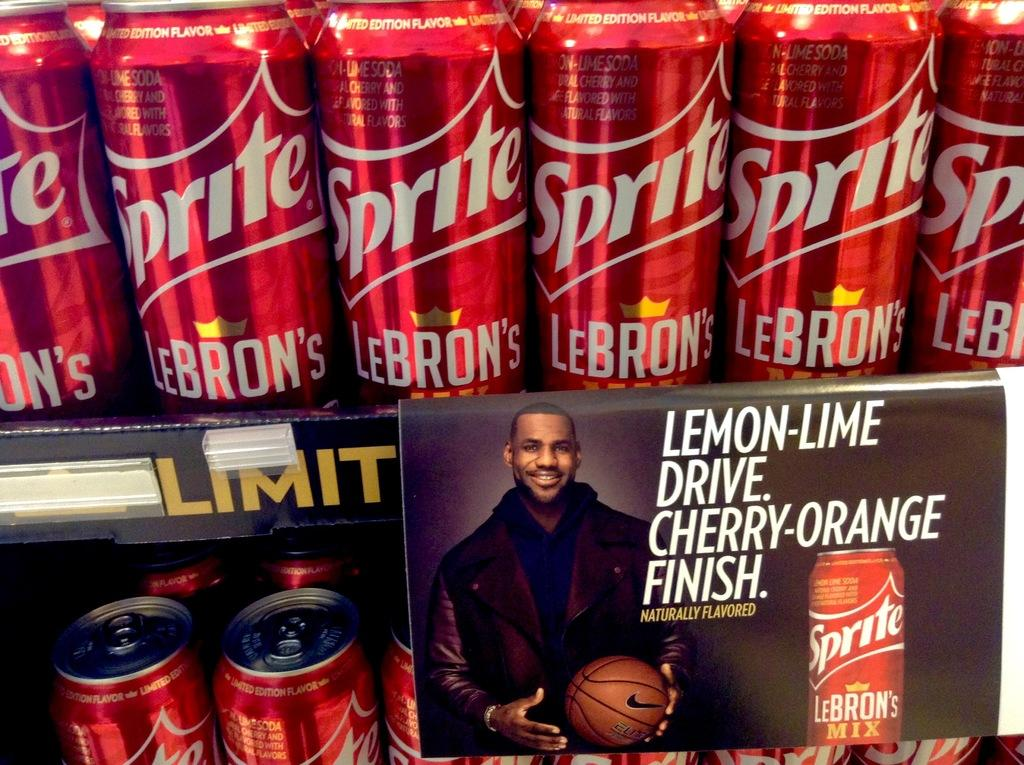<image>
Describe the image concisely. Two racks of sprite in a store and a poster that says Lemon-Lime Dive Cherry orange Finish. 